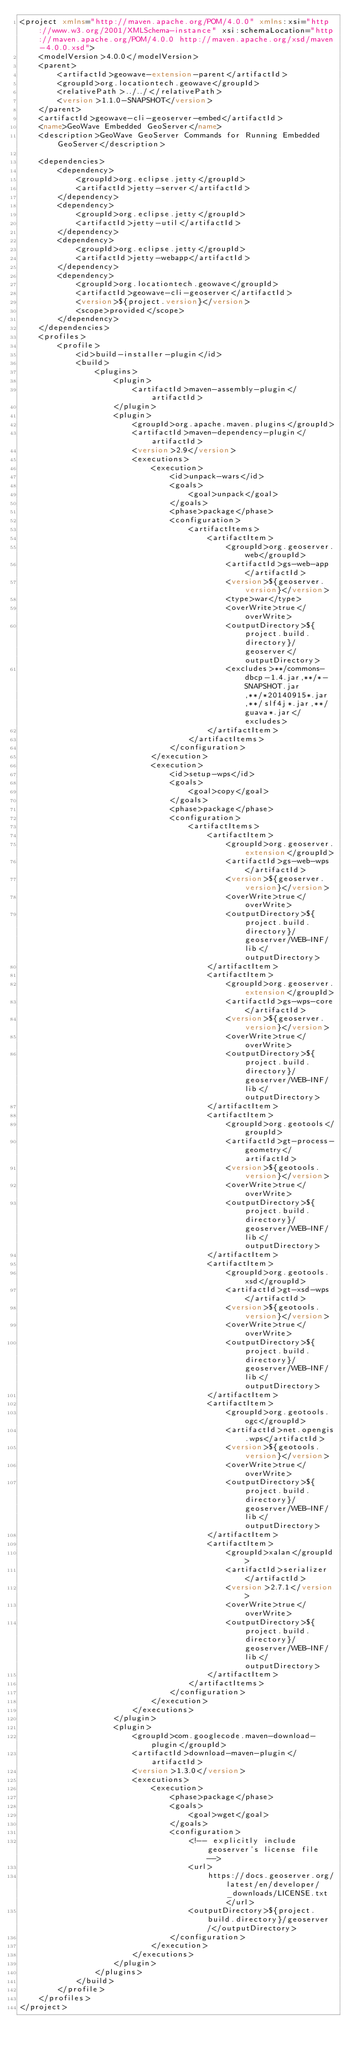<code> <loc_0><loc_0><loc_500><loc_500><_XML_><project xmlns="http://maven.apache.org/POM/4.0.0" xmlns:xsi="http://www.w3.org/2001/XMLSchema-instance" xsi:schemaLocation="http://maven.apache.org/POM/4.0.0 http://maven.apache.org/xsd/maven-4.0.0.xsd">
	<modelVersion>4.0.0</modelVersion>
	<parent>
		<artifactId>geowave-extension-parent</artifactId>
		<groupId>org.locationtech.geowave</groupId>
		<relativePath>../../</relativePath>
		<version>1.1.0-SNAPSHOT</version>
	</parent>
	<artifactId>geowave-cli-geoserver-embed</artifactId>
	<name>GeoWave Embedded GeoServer</name>
	<description>GeoWave GeoServer Commands for Running Embedded GeoServer</description>

	<dependencies>
		<dependency>
			<groupId>org.eclipse.jetty</groupId>
			<artifactId>jetty-server</artifactId>
		</dependency>
		<dependency>
			<groupId>org.eclipse.jetty</groupId>
			<artifactId>jetty-util</artifactId>
		</dependency>
		<dependency>
			<groupId>org.eclipse.jetty</groupId>
			<artifactId>jetty-webapp</artifactId>
		</dependency>
		<dependency>
			<groupId>org.locationtech.geowave</groupId>
			<artifactId>geowave-cli-geoserver</artifactId>
			<version>${project.version}</version>
			<scope>provided</scope>
		</dependency>
	</dependencies>
	<profiles>
		<profile>
			<id>build-installer-plugin</id>
			<build>
				<plugins>
					<plugin>
						<artifactId>maven-assembly-plugin</artifactId>
					</plugin>
					<plugin>
						<groupId>org.apache.maven.plugins</groupId>
						<artifactId>maven-dependency-plugin</artifactId>
						<version>2.9</version>
						<executions>
							<execution>
								<id>unpack-wars</id>
								<goals>
									<goal>unpack</goal>
								</goals>
								<phase>package</phase>
								<configuration>
									<artifactItems>
										<artifactItem>
											<groupId>org.geoserver.web</groupId>
											<artifactId>gs-web-app</artifactId>
											<version>${geoserver.version}</version>
											<type>war</type>
											<overWrite>true</overWrite>
											<outputDirectory>${project.build.directory}/geoserver</outputDirectory>
											<excludes>**/commons-dbcp-1.4.jar,**/*-SNAPSHOT.jar,**/*20140915*.jar,**/slf4j*.jar,**/guava*.jar</excludes>
										</artifactItem>
									</artifactItems>
								</configuration>
							</execution>
							<execution>
								<id>setup-wps</id>
								<goals>
									<goal>copy</goal>
								</goals>
								<phase>package</phase>
								<configuration>
									<artifactItems>
										<artifactItem>
											<groupId>org.geoserver.extension</groupId>
											<artifactId>gs-web-wps</artifactId>
											<version>${geoserver.version}</version>
											<overWrite>true</overWrite>
											<outputDirectory>${project.build.directory}/geoserver/WEB-INF/lib</outputDirectory>
										</artifactItem>
										<artifactItem>
											<groupId>org.geoserver.extension</groupId>
											<artifactId>gs-wps-core</artifactId>
											<version>${geoserver.version}</version>
											<overWrite>true</overWrite>
											<outputDirectory>${project.build.directory}/geoserver/WEB-INF/lib</outputDirectory>
										</artifactItem>
										<artifactItem>
											<groupId>org.geotools</groupId>
											<artifactId>gt-process-geometry</artifactId>
											<version>${geotools.version}</version>
											<overWrite>true</overWrite>
											<outputDirectory>${project.build.directory}/geoserver/WEB-INF/lib</outputDirectory>
										</artifactItem>
										<artifactItem>
											<groupId>org.geotools.xsd</groupId>
											<artifactId>gt-xsd-wps</artifactId>
											<version>${geotools.version}</version>
											<overWrite>true</overWrite>
											<outputDirectory>${project.build.directory}/geoserver/WEB-INF/lib</outputDirectory>
										</artifactItem>
										<artifactItem>
											<groupId>org.geotools.ogc</groupId>
											<artifactId>net.opengis.wps</artifactId>
											<version>${geotools.version}</version>
											<overWrite>true</overWrite>
											<outputDirectory>${project.build.directory}/geoserver/WEB-INF/lib</outputDirectory>
										</artifactItem>
										<artifactItem>
											<groupId>xalan</groupId>
											<artifactId>serializer</artifactId>
											<version>2.7.1</version>
											<overWrite>true</overWrite>
											<outputDirectory>${project.build.directory}/geoserver/WEB-INF/lib</outputDirectory>
										</artifactItem>
									</artifactItems>
								</configuration>
							</execution>
						</executions>
					</plugin>
					<plugin>
						<groupId>com.googlecode.maven-download-plugin</groupId>
						<artifactId>download-maven-plugin</artifactId>
						<version>1.3.0</version>
						<executions>
							<execution>
								<phase>package</phase>
								<goals>
									<goal>wget</goal>
								</goals>
								<configuration>
									<!-- explicitly include geoserver's license file -->
									<url>
										https://docs.geoserver.org/latest/en/developer/_downloads/LICENSE.txt</url>
									<outputDirectory>${project.build.directory}/geoserver/</outputDirectory>
								</configuration>
							</execution>
						</executions>
					</plugin>
				</plugins>
			</build>
		</profile>
	</profiles>
</project>
</code> 